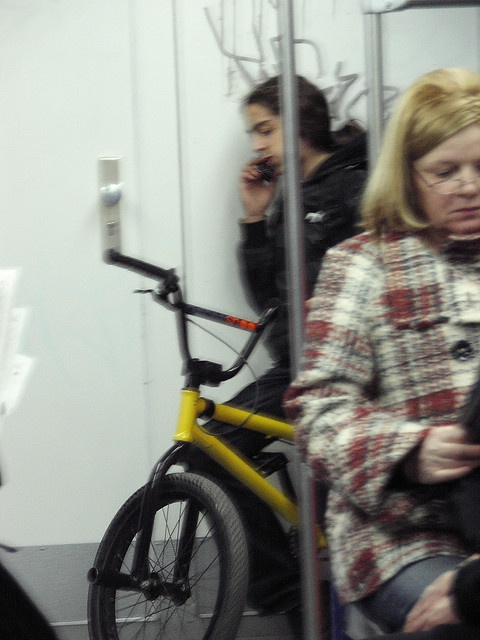Describe the objects in this image and their specific colors. I can see people in lightgray, gray, darkgray, and black tones, bicycle in lightgray, black, gray, darkgray, and olive tones, people in lightgray, black, and gray tones, book in lightgray, black, and gray tones, and cell phone in lightgray, black, brown, and purple tones in this image. 